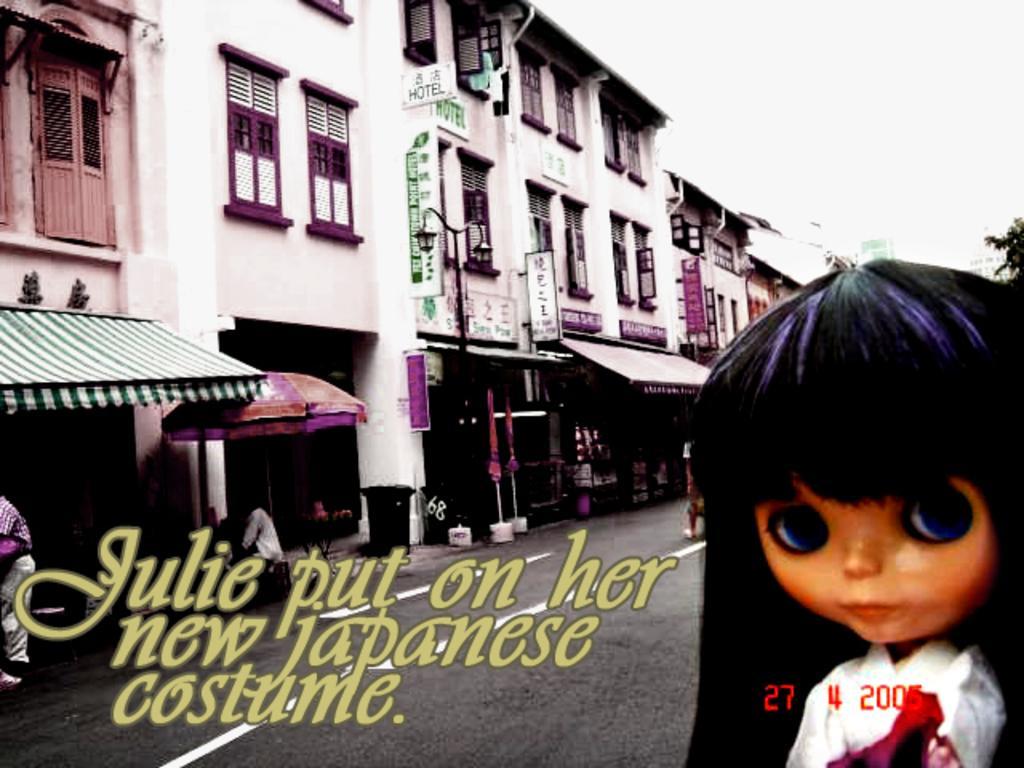How would you summarize this image in a sentence or two? There are few buildings in the left corner and there is a doll in the right corner and there are something written beside it. 